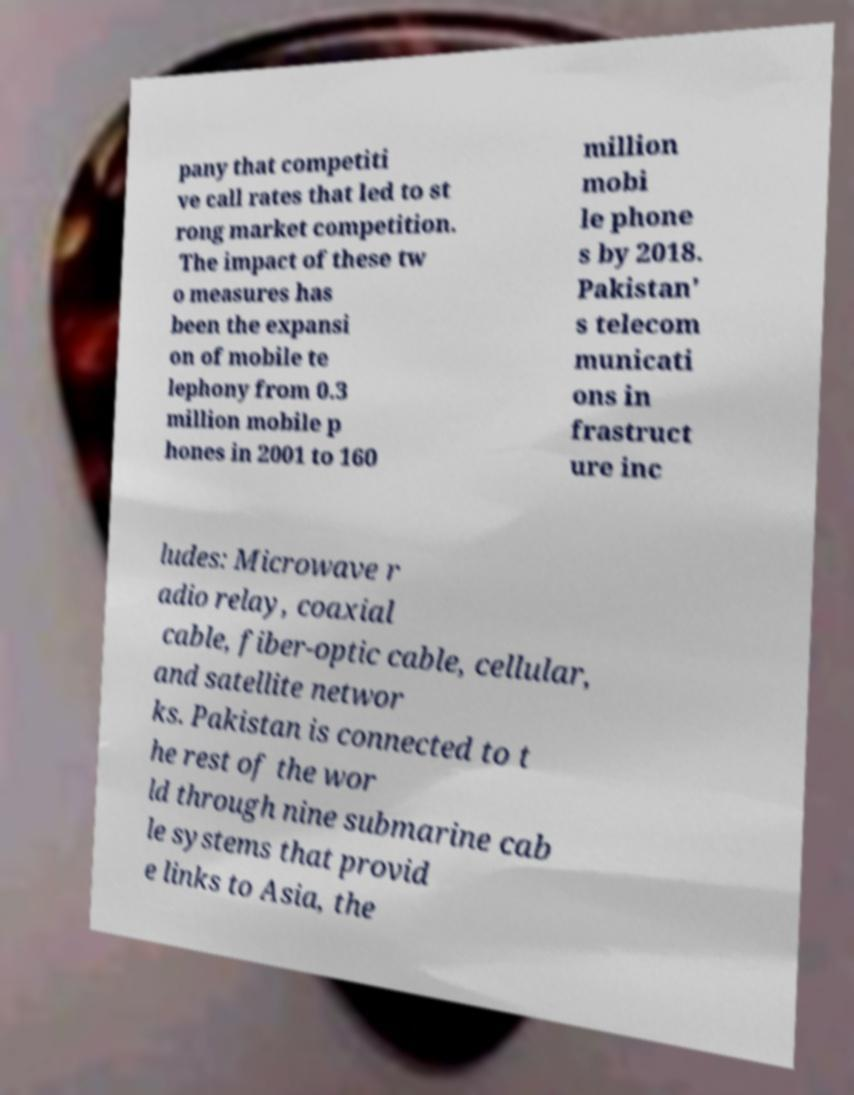Can you accurately transcribe the text from the provided image for me? pany that competiti ve call rates that led to st rong market competition. The impact of these tw o measures has been the expansi on of mobile te lephony from 0.3 million mobile p hones in 2001 to 160 million mobi le phone s by 2018. Pakistan' s telecom municati ons in frastruct ure inc ludes: Microwave r adio relay, coaxial cable, fiber-optic cable, cellular, and satellite networ ks. Pakistan is connected to t he rest of the wor ld through nine submarine cab le systems that provid e links to Asia, the 